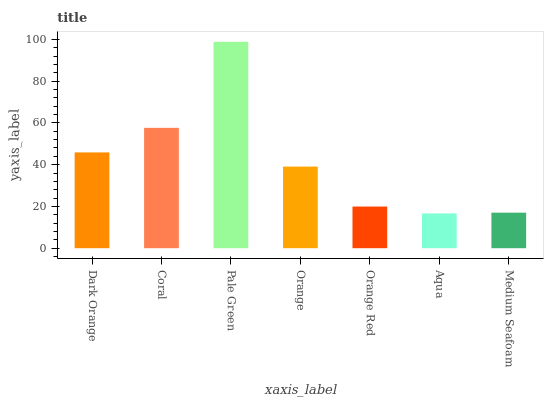Is Aqua the minimum?
Answer yes or no. Yes. Is Pale Green the maximum?
Answer yes or no. Yes. Is Coral the minimum?
Answer yes or no. No. Is Coral the maximum?
Answer yes or no. No. Is Coral greater than Dark Orange?
Answer yes or no. Yes. Is Dark Orange less than Coral?
Answer yes or no. Yes. Is Dark Orange greater than Coral?
Answer yes or no. No. Is Coral less than Dark Orange?
Answer yes or no. No. Is Orange the high median?
Answer yes or no. Yes. Is Orange the low median?
Answer yes or no. Yes. Is Coral the high median?
Answer yes or no. No. Is Medium Seafoam the low median?
Answer yes or no. No. 